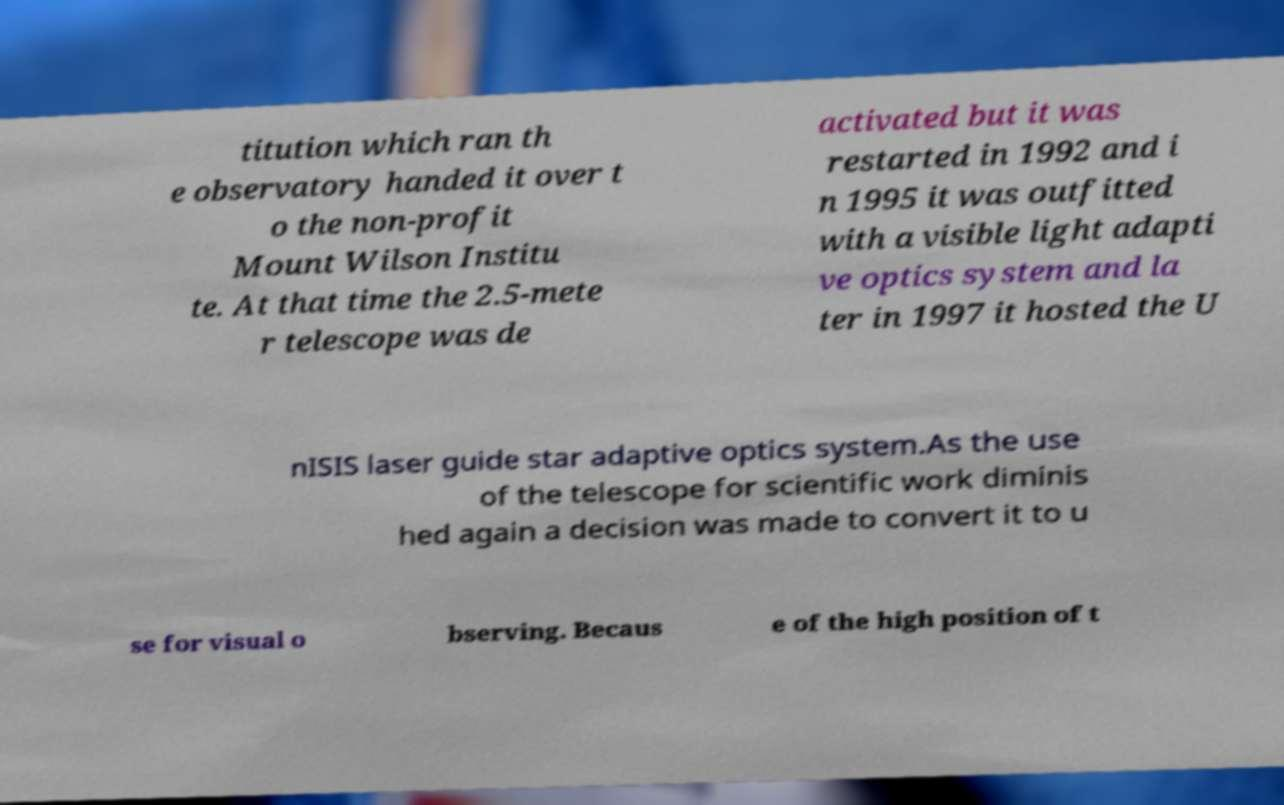What messages or text are displayed in this image? I need them in a readable, typed format. titution which ran th e observatory handed it over t o the non-profit Mount Wilson Institu te. At that time the 2.5-mete r telescope was de activated but it was restarted in 1992 and i n 1995 it was outfitted with a visible light adapti ve optics system and la ter in 1997 it hosted the U nISIS laser guide star adaptive optics system.As the use of the telescope for scientific work diminis hed again a decision was made to convert it to u se for visual o bserving. Becaus e of the high position of t 